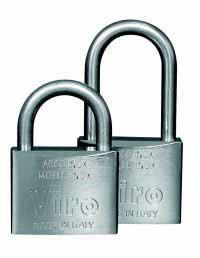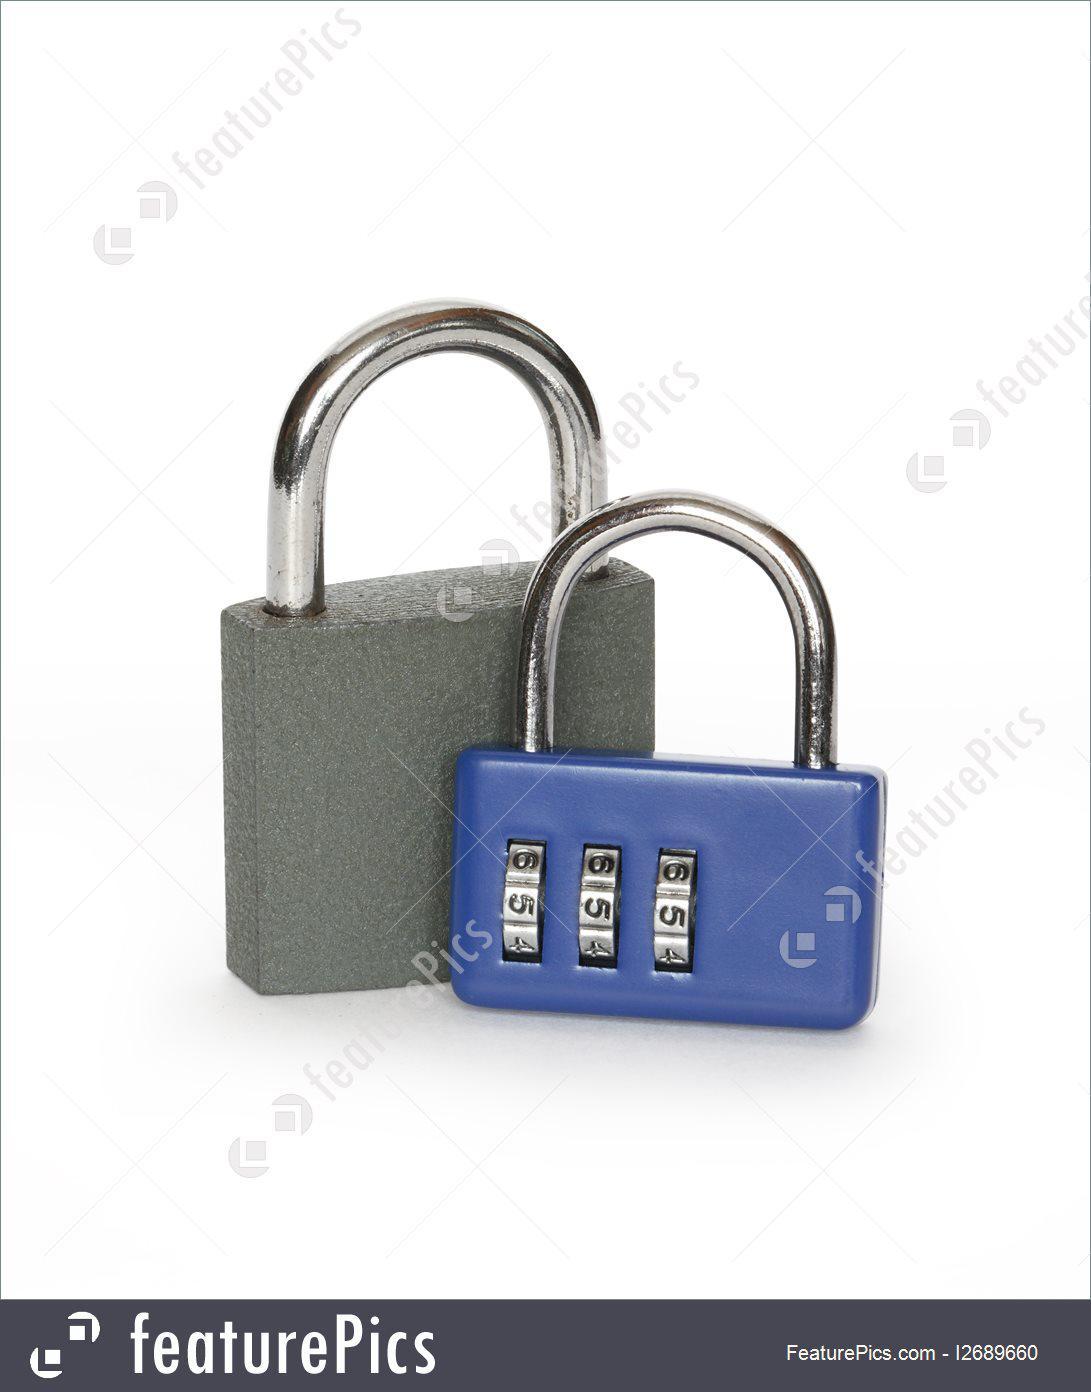The first image is the image on the left, the second image is the image on the right. Examine the images to the left and right. Is the description "There are four padlocks, all of which are closed." accurate? Answer yes or no. Yes. The first image is the image on the left, the second image is the image on the right. Analyze the images presented: Is the assertion "Multiple keys are next to a pair of the same type locks in one image." valid? Answer yes or no. No. 